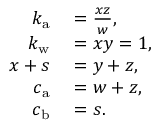<formula> <loc_0><loc_0><loc_500><loc_500>\begin{array} { r l } { k _ { a } } & = \frac { x z } { w } , } \\ { k _ { w } } & = x y = 1 , } \\ { x + s } & = y + z , } \\ { c _ { a } } & = w + z , } \\ { c _ { b } } & = s . } \end{array}</formula> 